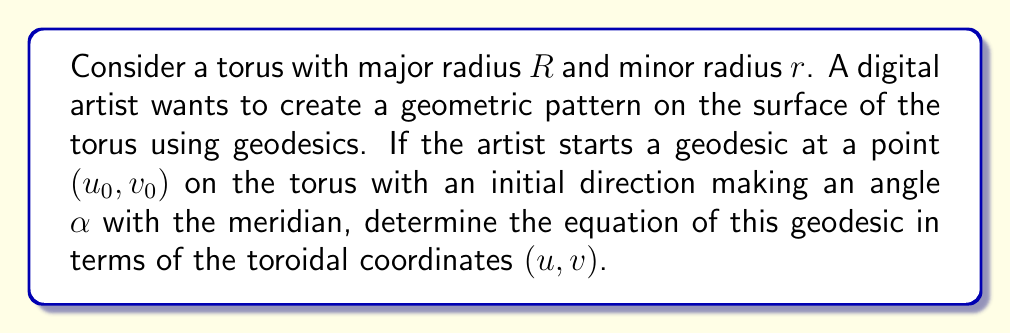Show me your answer to this math problem. To solve this problem, we need to follow these steps:

1) First, recall that the parametric equations of a torus in Cartesian coordinates are:
   
   $x = (R + r\cos v)\cos u$
   $y = (R + r\cos v)\sin u$
   $z = r\sin v$

   where $u$ is the angle around the tube and $v$ is the angle around the axis of rotation.

2) The geodesic equations on a torus can be derived using the Euler-Lagrange equations. They are:

   $$\frac{d^2u}{ds^2} + \frac{2r\sin v}{R + r\cos v}\frac{du}{ds}\frac{dv}{ds} = 0$$
   
   $$\frac{d^2v}{ds^2} - (R + r\cos v)\sin v\left(\frac{du}{ds}\right)^2 = 0$$

   where $s$ is the arc length parameter.

3) These equations can be simplified by introducing a constant of motion $c$:

   $$(R + r\cos v)\frac{du}{ds} = c$$

4) Using this, we can derive the equation of the geodesic:

   $$\frac{dv}{du} = \pm \sqrt{\frac{(R + r\cos v)^2}{c^2} - 1}$$

5) The constant $c$ is related to the initial angle $\alpha$ by:

   $$c = (R + r\cos v_0)\cos\alpha$$

6) Therefore, the equation of the geodesic becomes:

   $$\frac{dv}{du} = \pm \sqrt{\frac{(R + r\cos v)^2}{(R + r\cos v_0)^2\cos^2\alpha} - 1}$$

7) This differential equation can be solved numerically to plot the geodesic on the torus.

8) For the artistic application, multiple geodesics can be plotted with different starting points and initial angles to create intricate geometric patterns on the torus surface.
Answer: The equation of the geodesic on a torus in toroidal coordinates $(u, v)$, starting from point $(u_0, v_0)$ with initial angle $\alpha$ to the meridian, is:

$$\frac{dv}{du} = \pm \sqrt{\frac{(R + r\cos v)^2}{(R + r\cos v_0)^2\cos^2\alpha} - 1}$$

where $R$ is the major radius and $r$ is the minor radius of the torus. 